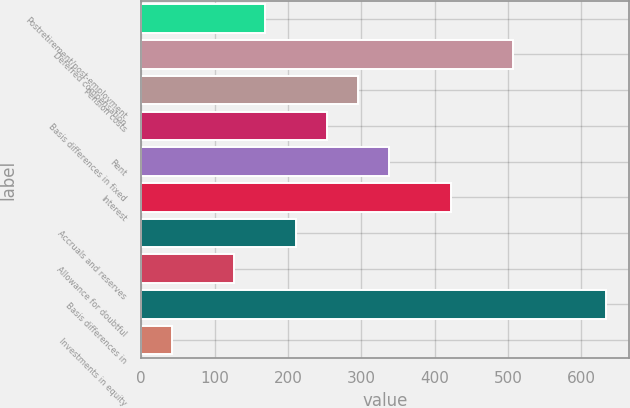Convert chart. <chart><loc_0><loc_0><loc_500><loc_500><bar_chart><fcel>Postretirement/post-employment<fcel>Deferred compensation<fcel>Pension costs<fcel>Basis differences in fixed<fcel>Rent<fcel>Interest<fcel>Accruals and reserves<fcel>Allowance for doubtful<fcel>Basis differences in<fcel>Investments in equity<nl><fcel>169.06<fcel>506.58<fcel>295.63<fcel>253.44<fcel>337.82<fcel>422.2<fcel>211.25<fcel>126.87<fcel>633.15<fcel>42.49<nl></chart> 